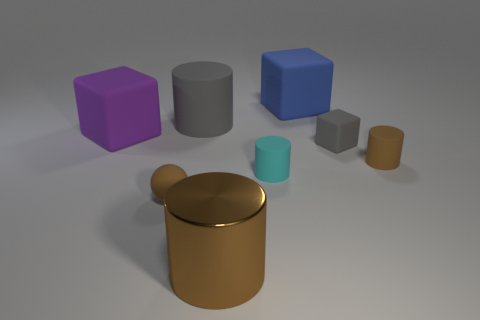Add 1 tiny yellow rubber things. How many objects exist? 9 Subtract all balls. How many objects are left? 7 Add 6 big red rubber cubes. How many big red rubber cubes exist? 6 Subtract 1 purple blocks. How many objects are left? 7 Subtract all brown rubber objects. Subtract all big blue cubes. How many objects are left? 5 Add 5 brown matte objects. How many brown matte objects are left? 7 